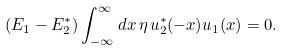Convert formula to latex. <formula><loc_0><loc_0><loc_500><loc_500>( E _ { 1 } - E _ { 2 } ^ { * } ) \int _ { - \infty } ^ { \infty } d x \, \eta \, u _ { 2 } ^ { * } ( - x ) u _ { 1 } ( x ) = 0 .</formula> 